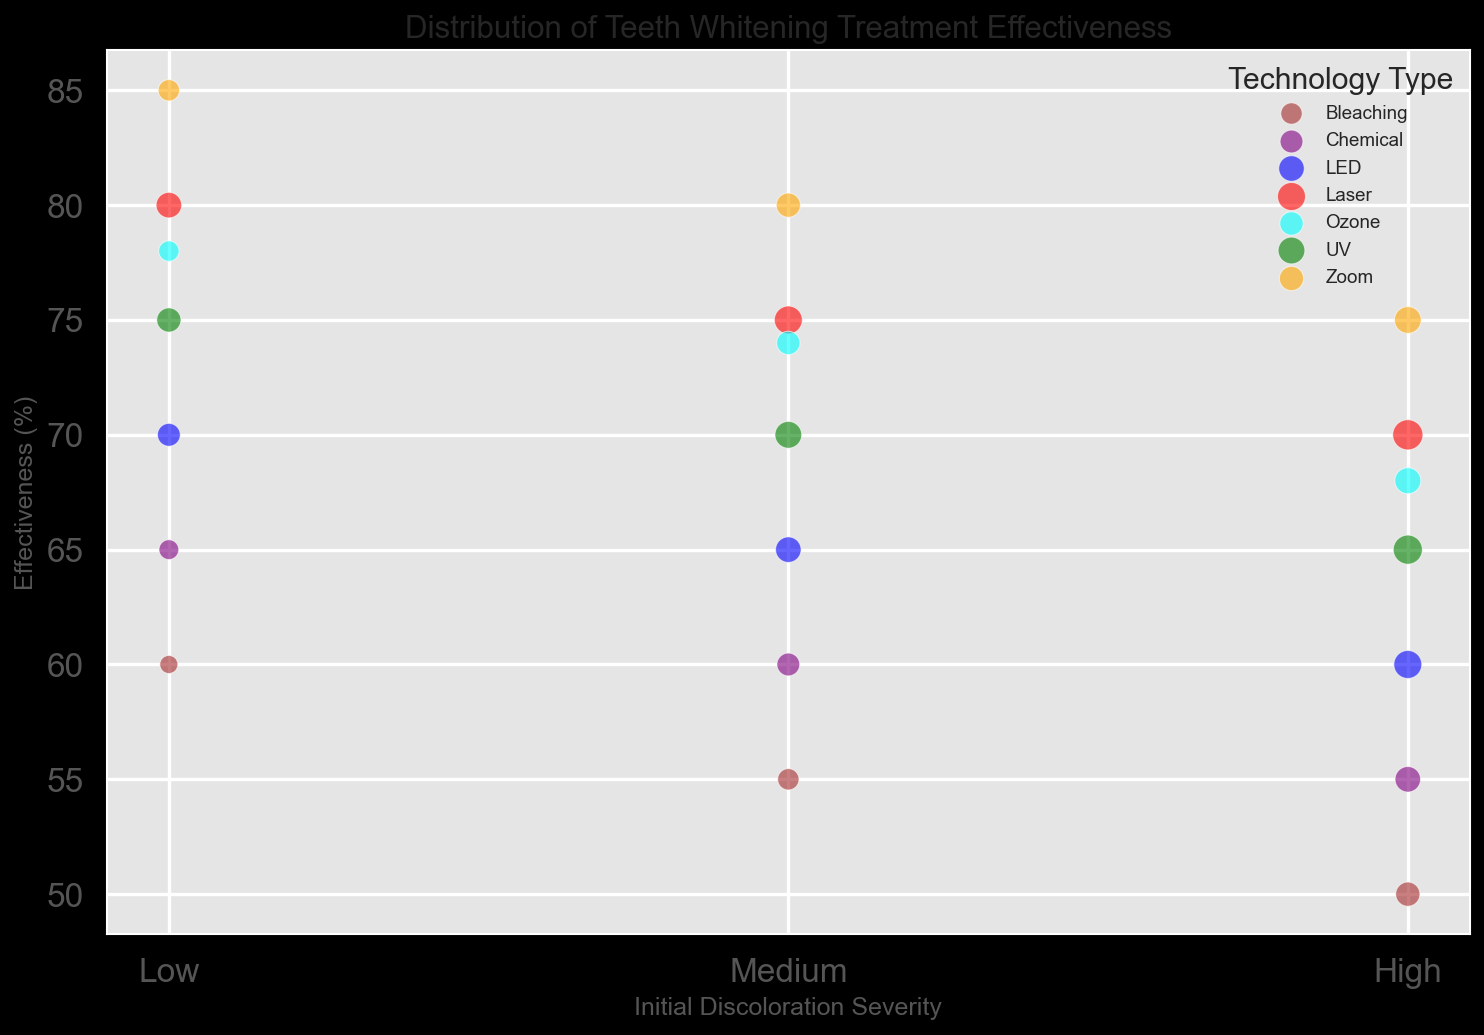Which technology type shows the highest effectiveness for low initial discoloration severity? For low initial discoloration severity, locate the highest point on the y-axis. This point corresponds to the "Zoom" technology with an effectiveness of 85%.
Answer: Zoom How does the effectiveness of LED compare to UV for medium initial discoloration severity? For medium initial discoloration severity, find the points for both LED and UV. LED has an effectiveness of 65%, while UV has 70%. Therefore, UV performs better.
Answer: UV Which technology has the largest bubble size (i.e., most number of patients) in the high initial discoloration severity category? For high initial discoloration severity, inspect the bubble sizes. The largest bubble is for the Laser technology, with 70 patients.
Answer: Laser Which technology type shows the lowest effectiveness overall? Inspect all points and identify the minimum value on the y-axis. The lowest effectiveness is 50%, which corresponds to Bleaching technology with high initial discoloration severity.
Answer: Bleaching Compare the average effectiveness of Laser and Chemical technologies across all initial discoloration severities. Calculate the average effectiveness for Laser: (80 + 75 + 70)/3 = 75%. For Chemical: (65 + 60 + 55)/3 = 60%. Laser has a higher average effectiveness compared to Chemical.
Answer: Laser Among the technologies with medium initial discoloration severity, which one has the second highest effectiveness and what is its effectiveness percentage? For medium initial discoloration severity, the effectiveness values are Zoom (80), Laser (75), UV (70), LED (65), Ozone (74), Chemical (60), and Bleaching (55). The second highest is Laser with effectiveness of 75%.
Answer: Laser, 75% What is the effectiveness difference between the highest and lowest effectiveness technologies for low initial discoloration severity? For low initial discoloration severity, the effectiveness values are Zoom (85), Laser (80), UV (75), Ozone (78), LED (70), Chemical (65), and Bleaching (60). The difference between highest (Zoom, 85) and lowest (Bleaching, 60) is 85 - 60 = 25%.
Answer: 25% How many patients were treated using UV technology for medium initial discoloration severity? Locate the bubble representing UV technology for medium initial discoloration severity. The number of patients is 55.
Answer: 55 What is the relationship between initial discoloration severity and effectiveness for Laser technology? Observe the effectiveness values for Laser at low, medium, and high initial discoloration severities; they are 80%, 75%, and 70% respectively. Effectiveness decreases as initial discoloration severity increases.
Answer: Decreases Which technology shows a significant drop in effectiveness as the initial discoloration severity increases from low to high? Compare the effectiveness across severities for all technologies. Bleaching shows a distinctive drop from 60% (low) to 50% (high).
Answer: Bleaching 